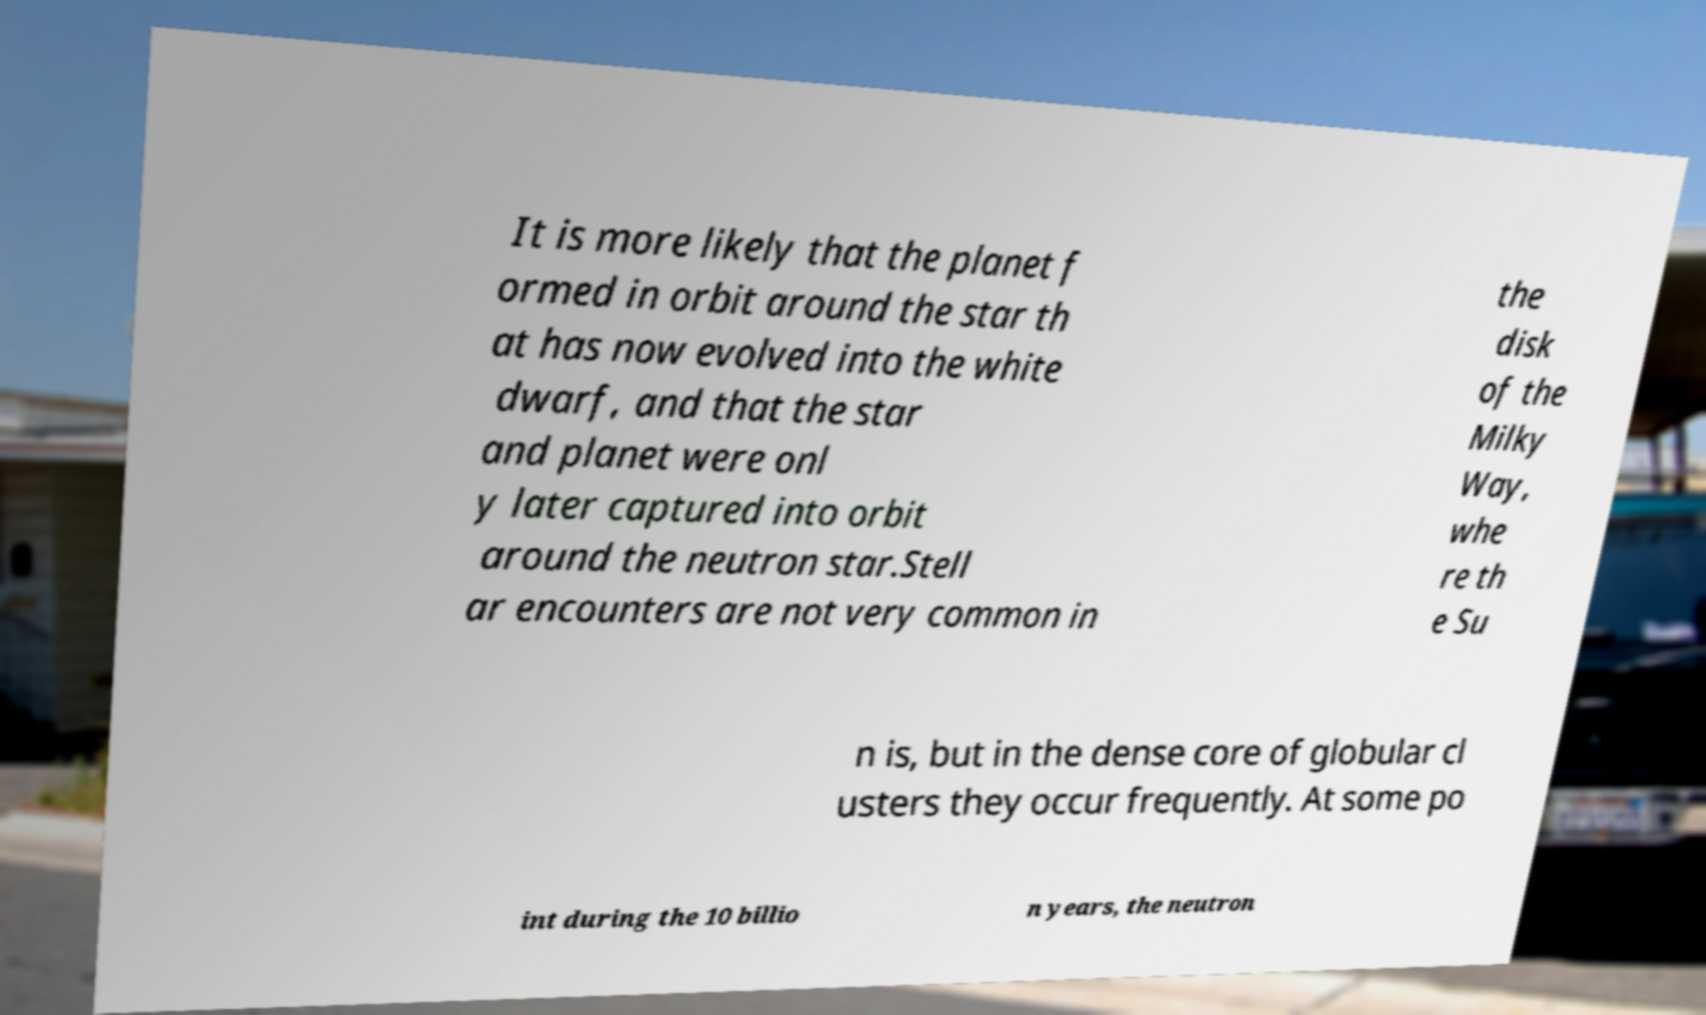Could you extract and type out the text from this image? It is more likely that the planet f ormed in orbit around the star th at has now evolved into the white dwarf, and that the star and planet were onl y later captured into orbit around the neutron star.Stell ar encounters are not very common in the disk of the Milky Way, whe re th e Su n is, but in the dense core of globular cl usters they occur frequently. At some po int during the 10 billio n years, the neutron 